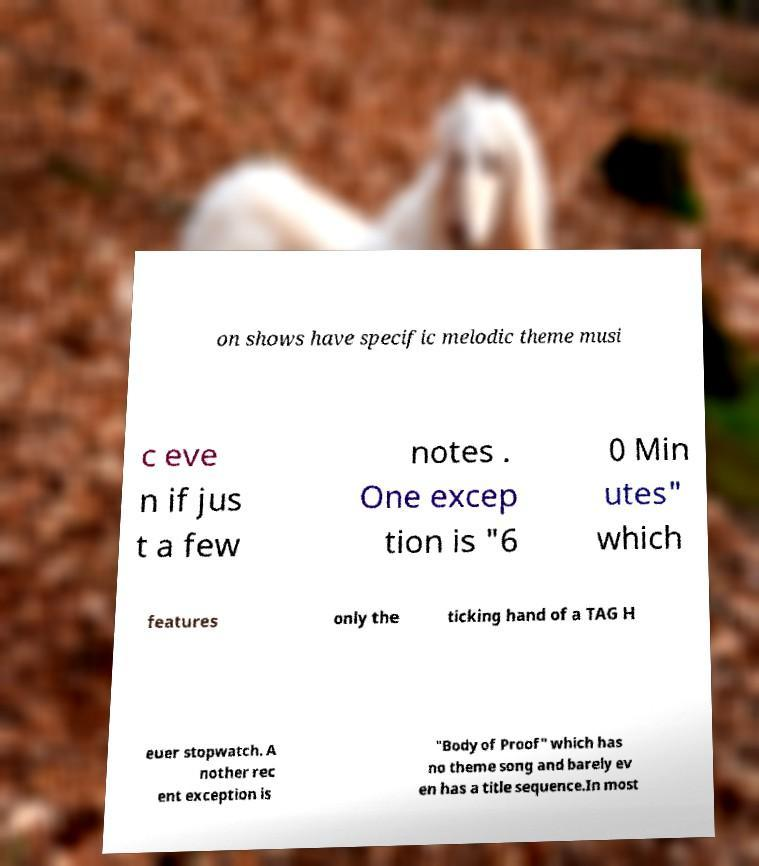What messages or text are displayed in this image? I need them in a readable, typed format. on shows have specific melodic theme musi c eve n if jus t a few notes . One excep tion is "6 0 Min utes" which features only the ticking hand of a TAG H euer stopwatch. A nother rec ent exception is "Body of Proof" which has no theme song and barely ev en has a title sequence.In most 